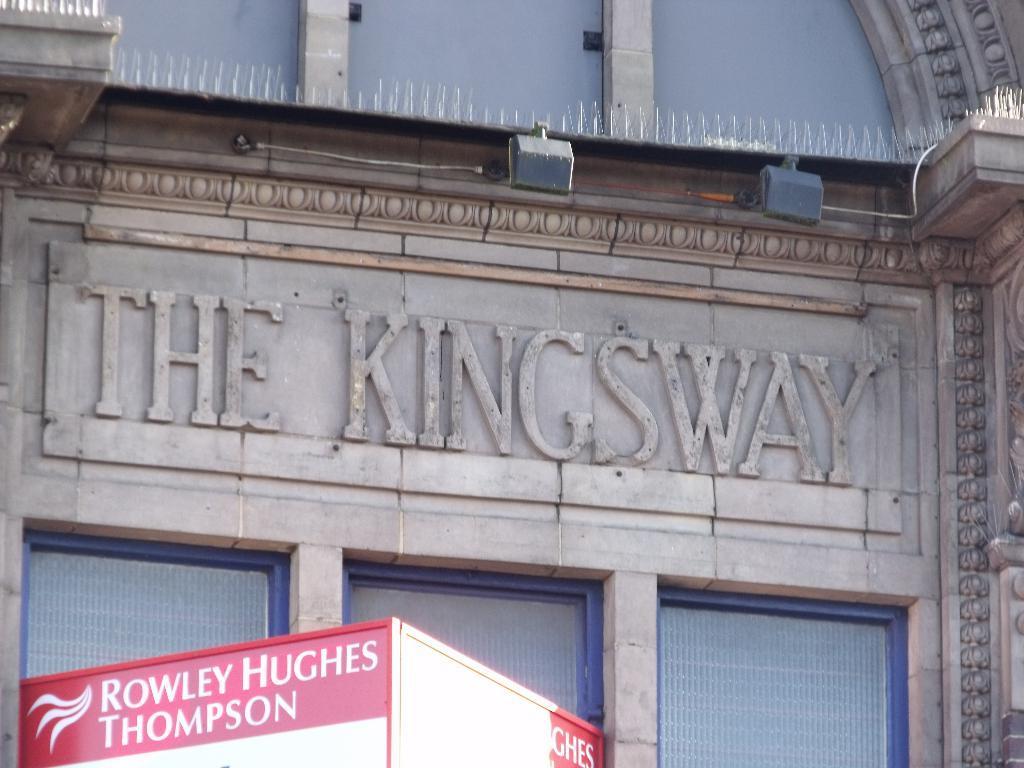Can you describe this image briefly? In the image I can see a building which is brown in color and a red colored board to the building. I can see few lights, a wire and something is written on the building. 